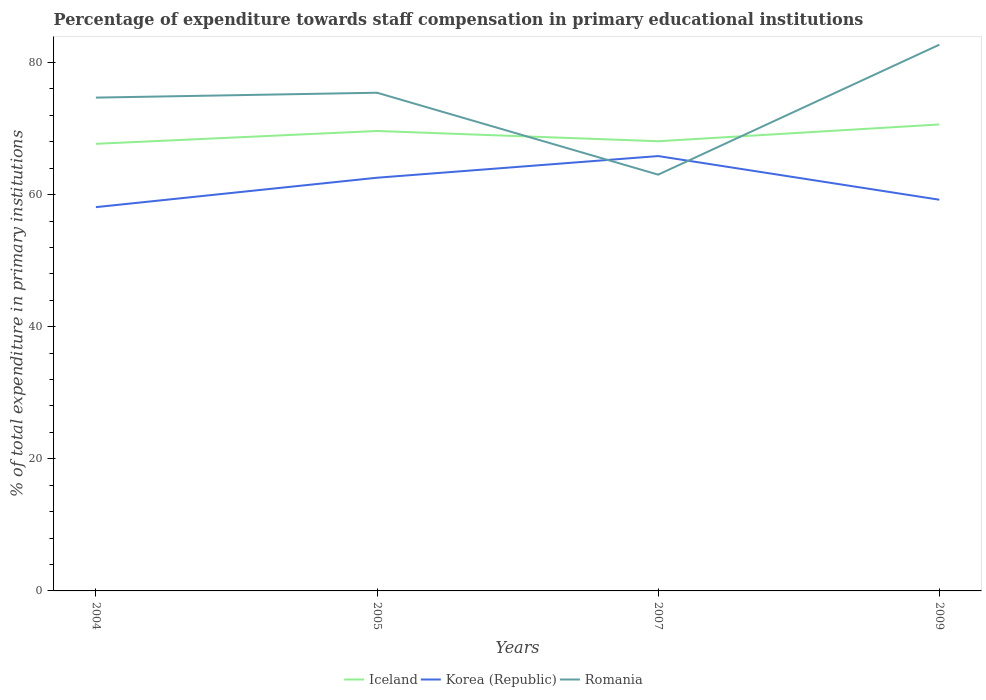How many different coloured lines are there?
Keep it short and to the point. 3. Does the line corresponding to Korea (Republic) intersect with the line corresponding to Romania?
Keep it short and to the point. Yes. Across all years, what is the maximum percentage of expenditure towards staff compensation in Korea (Republic)?
Your answer should be very brief. 58.11. What is the total percentage of expenditure towards staff compensation in Iceland in the graph?
Provide a short and direct response. -0.39. What is the difference between the highest and the second highest percentage of expenditure towards staff compensation in Korea (Republic)?
Make the answer very short. 7.73. What is the difference between the highest and the lowest percentage of expenditure towards staff compensation in Romania?
Provide a succinct answer. 3. Is the percentage of expenditure towards staff compensation in Romania strictly greater than the percentage of expenditure towards staff compensation in Korea (Republic) over the years?
Your answer should be compact. No. How many lines are there?
Your answer should be compact. 3. How many years are there in the graph?
Give a very brief answer. 4. What is the difference between two consecutive major ticks on the Y-axis?
Provide a short and direct response. 20. Are the values on the major ticks of Y-axis written in scientific E-notation?
Give a very brief answer. No. Does the graph contain grids?
Provide a succinct answer. No. How are the legend labels stacked?
Give a very brief answer. Horizontal. What is the title of the graph?
Provide a succinct answer. Percentage of expenditure towards staff compensation in primary educational institutions. What is the label or title of the Y-axis?
Give a very brief answer. % of total expenditure in primary institutions. What is the % of total expenditure in primary institutions of Iceland in 2004?
Your response must be concise. 67.7. What is the % of total expenditure in primary institutions of Korea (Republic) in 2004?
Give a very brief answer. 58.11. What is the % of total expenditure in primary institutions in Romania in 2004?
Provide a short and direct response. 74.69. What is the % of total expenditure in primary institutions in Iceland in 2005?
Give a very brief answer. 69.64. What is the % of total expenditure in primary institutions of Korea (Republic) in 2005?
Your response must be concise. 62.56. What is the % of total expenditure in primary institutions in Romania in 2005?
Make the answer very short. 75.43. What is the % of total expenditure in primary institutions of Iceland in 2007?
Ensure brevity in your answer.  68.09. What is the % of total expenditure in primary institutions in Korea (Republic) in 2007?
Your answer should be compact. 65.84. What is the % of total expenditure in primary institutions of Romania in 2007?
Ensure brevity in your answer.  63.03. What is the % of total expenditure in primary institutions in Iceland in 2009?
Give a very brief answer. 70.63. What is the % of total expenditure in primary institutions in Korea (Republic) in 2009?
Make the answer very short. 59.23. What is the % of total expenditure in primary institutions in Romania in 2009?
Offer a very short reply. 82.7. Across all years, what is the maximum % of total expenditure in primary institutions in Iceland?
Offer a terse response. 70.63. Across all years, what is the maximum % of total expenditure in primary institutions of Korea (Republic)?
Keep it short and to the point. 65.84. Across all years, what is the maximum % of total expenditure in primary institutions in Romania?
Your response must be concise. 82.7. Across all years, what is the minimum % of total expenditure in primary institutions in Iceland?
Your response must be concise. 67.7. Across all years, what is the minimum % of total expenditure in primary institutions in Korea (Republic)?
Your response must be concise. 58.11. Across all years, what is the minimum % of total expenditure in primary institutions of Romania?
Your response must be concise. 63.03. What is the total % of total expenditure in primary institutions of Iceland in the graph?
Keep it short and to the point. 276.04. What is the total % of total expenditure in primary institutions in Korea (Republic) in the graph?
Offer a very short reply. 245.74. What is the total % of total expenditure in primary institutions in Romania in the graph?
Your answer should be very brief. 295.85. What is the difference between the % of total expenditure in primary institutions of Iceland in 2004 and that in 2005?
Your response must be concise. -1.94. What is the difference between the % of total expenditure in primary institutions of Korea (Republic) in 2004 and that in 2005?
Your answer should be compact. -4.45. What is the difference between the % of total expenditure in primary institutions of Romania in 2004 and that in 2005?
Ensure brevity in your answer.  -0.74. What is the difference between the % of total expenditure in primary institutions of Iceland in 2004 and that in 2007?
Ensure brevity in your answer.  -0.39. What is the difference between the % of total expenditure in primary institutions in Korea (Republic) in 2004 and that in 2007?
Make the answer very short. -7.73. What is the difference between the % of total expenditure in primary institutions of Romania in 2004 and that in 2007?
Provide a short and direct response. 11.66. What is the difference between the % of total expenditure in primary institutions in Iceland in 2004 and that in 2009?
Offer a terse response. -2.93. What is the difference between the % of total expenditure in primary institutions of Korea (Republic) in 2004 and that in 2009?
Your answer should be compact. -1.12. What is the difference between the % of total expenditure in primary institutions in Romania in 2004 and that in 2009?
Your response must be concise. -8.01. What is the difference between the % of total expenditure in primary institutions in Iceland in 2005 and that in 2007?
Your answer should be compact. 1.55. What is the difference between the % of total expenditure in primary institutions in Korea (Republic) in 2005 and that in 2007?
Make the answer very short. -3.28. What is the difference between the % of total expenditure in primary institutions in Romania in 2005 and that in 2007?
Give a very brief answer. 12.4. What is the difference between the % of total expenditure in primary institutions in Iceland in 2005 and that in 2009?
Give a very brief answer. -0.99. What is the difference between the % of total expenditure in primary institutions of Korea (Republic) in 2005 and that in 2009?
Your response must be concise. 3.33. What is the difference between the % of total expenditure in primary institutions in Romania in 2005 and that in 2009?
Provide a short and direct response. -7.27. What is the difference between the % of total expenditure in primary institutions of Iceland in 2007 and that in 2009?
Your answer should be very brief. -2.54. What is the difference between the % of total expenditure in primary institutions in Korea (Republic) in 2007 and that in 2009?
Your response must be concise. 6.61. What is the difference between the % of total expenditure in primary institutions in Romania in 2007 and that in 2009?
Provide a succinct answer. -19.67. What is the difference between the % of total expenditure in primary institutions of Iceland in 2004 and the % of total expenditure in primary institutions of Korea (Republic) in 2005?
Offer a very short reply. 5.14. What is the difference between the % of total expenditure in primary institutions of Iceland in 2004 and the % of total expenditure in primary institutions of Romania in 2005?
Give a very brief answer. -7.73. What is the difference between the % of total expenditure in primary institutions of Korea (Republic) in 2004 and the % of total expenditure in primary institutions of Romania in 2005?
Keep it short and to the point. -17.32. What is the difference between the % of total expenditure in primary institutions of Iceland in 2004 and the % of total expenditure in primary institutions of Korea (Republic) in 2007?
Ensure brevity in your answer.  1.86. What is the difference between the % of total expenditure in primary institutions in Iceland in 2004 and the % of total expenditure in primary institutions in Romania in 2007?
Offer a very short reply. 4.67. What is the difference between the % of total expenditure in primary institutions of Korea (Republic) in 2004 and the % of total expenditure in primary institutions of Romania in 2007?
Give a very brief answer. -4.92. What is the difference between the % of total expenditure in primary institutions of Iceland in 2004 and the % of total expenditure in primary institutions of Korea (Republic) in 2009?
Provide a succinct answer. 8.47. What is the difference between the % of total expenditure in primary institutions of Iceland in 2004 and the % of total expenditure in primary institutions of Romania in 2009?
Keep it short and to the point. -15.01. What is the difference between the % of total expenditure in primary institutions of Korea (Republic) in 2004 and the % of total expenditure in primary institutions of Romania in 2009?
Offer a terse response. -24.59. What is the difference between the % of total expenditure in primary institutions in Iceland in 2005 and the % of total expenditure in primary institutions in Korea (Republic) in 2007?
Offer a terse response. 3.8. What is the difference between the % of total expenditure in primary institutions of Iceland in 2005 and the % of total expenditure in primary institutions of Romania in 2007?
Your response must be concise. 6.61. What is the difference between the % of total expenditure in primary institutions of Korea (Republic) in 2005 and the % of total expenditure in primary institutions of Romania in 2007?
Ensure brevity in your answer.  -0.47. What is the difference between the % of total expenditure in primary institutions in Iceland in 2005 and the % of total expenditure in primary institutions in Korea (Republic) in 2009?
Give a very brief answer. 10.41. What is the difference between the % of total expenditure in primary institutions of Iceland in 2005 and the % of total expenditure in primary institutions of Romania in 2009?
Provide a succinct answer. -13.06. What is the difference between the % of total expenditure in primary institutions in Korea (Republic) in 2005 and the % of total expenditure in primary institutions in Romania in 2009?
Give a very brief answer. -20.14. What is the difference between the % of total expenditure in primary institutions of Iceland in 2007 and the % of total expenditure in primary institutions of Korea (Republic) in 2009?
Your response must be concise. 8.86. What is the difference between the % of total expenditure in primary institutions in Iceland in 2007 and the % of total expenditure in primary institutions in Romania in 2009?
Your response must be concise. -14.62. What is the difference between the % of total expenditure in primary institutions in Korea (Republic) in 2007 and the % of total expenditure in primary institutions in Romania in 2009?
Keep it short and to the point. -16.86. What is the average % of total expenditure in primary institutions of Iceland per year?
Give a very brief answer. 69.01. What is the average % of total expenditure in primary institutions of Korea (Republic) per year?
Keep it short and to the point. 61.43. What is the average % of total expenditure in primary institutions of Romania per year?
Offer a very short reply. 73.96. In the year 2004, what is the difference between the % of total expenditure in primary institutions of Iceland and % of total expenditure in primary institutions of Korea (Republic)?
Offer a terse response. 9.59. In the year 2004, what is the difference between the % of total expenditure in primary institutions in Iceland and % of total expenditure in primary institutions in Romania?
Provide a short and direct response. -6.99. In the year 2004, what is the difference between the % of total expenditure in primary institutions of Korea (Republic) and % of total expenditure in primary institutions of Romania?
Ensure brevity in your answer.  -16.58. In the year 2005, what is the difference between the % of total expenditure in primary institutions of Iceland and % of total expenditure in primary institutions of Korea (Republic)?
Offer a very short reply. 7.08. In the year 2005, what is the difference between the % of total expenditure in primary institutions of Iceland and % of total expenditure in primary institutions of Romania?
Make the answer very short. -5.79. In the year 2005, what is the difference between the % of total expenditure in primary institutions of Korea (Republic) and % of total expenditure in primary institutions of Romania?
Your answer should be very brief. -12.87. In the year 2007, what is the difference between the % of total expenditure in primary institutions in Iceland and % of total expenditure in primary institutions in Korea (Republic)?
Your answer should be very brief. 2.25. In the year 2007, what is the difference between the % of total expenditure in primary institutions in Iceland and % of total expenditure in primary institutions in Romania?
Your response must be concise. 5.06. In the year 2007, what is the difference between the % of total expenditure in primary institutions in Korea (Republic) and % of total expenditure in primary institutions in Romania?
Your response must be concise. 2.81. In the year 2009, what is the difference between the % of total expenditure in primary institutions in Iceland and % of total expenditure in primary institutions in Korea (Republic)?
Your response must be concise. 11.4. In the year 2009, what is the difference between the % of total expenditure in primary institutions in Iceland and % of total expenditure in primary institutions in Romania?
Your response must be concise. -12.08. In the year 2009, what is the difference between the % of total expenditure in primary institutions in Korea (Republic) and % of total expenditure in primary institutions in Romania?
Your answer should be very brief. -23.47. What is the ratio of the % of total expenditure in primary institutions in Iceland in 2004 to that in 2005?
Offer a very short reply. 0.97. What is the ratio of the % of total expenditure in primary institutions in Korea (Republic) in 2004 to that in 2005?
Keep it short and to the point. 0.93. What is the ratio of the % of total expenditure in primary institutions of Romania in 2004 to that in 2005?
Ensure brevity in your answer.  0.99. What is the ratio of the % of total expenditure in primary institutions in Iceland in 2004 to that in 2007?
Offer a terse response. 0.99. What is the ratio of the % of total expenditure in primary institutions of Korea (Republic) in 2004 to that in 2007?
Make the answer very short. 0.88. What is the ratio of the % of total expenditure in primary institutions of Romania in 2004 to that in 2007?
Your answer should be very brief. 1.19. What is the ratio of the % of total expenditure in primary institutions in Iceland in 2004 to that in 2009?
Offer a very short reply. 0.96. What is the ratio of the % of total expenditure in primary institutions in Romania in 2004 to that in 2009?
Your response must be concise. 0.9. What is the ratio of the % of total expenditure in primary institutions of Iceland in 2005 to that in 2007?
Your answer should be compact. 1.02. What is the ratio of the % of total expenditure in primary institutions in Korea (Republic) in 2005 to that in 2007?
Offer a very short reply. 0.95. What is the ratio of the % of total expenditure in primary institutions in Romania in 2005 to that in 2007?
Your answer should be very brief. 1.2. What is the ratio of the % of total expenditure in primary institutions in Korea (Republic) in 2005 to that in 2009?
Offer a terse response. 1.06. What is the ratio of the % of total expenditure in primary institutions of Romania in 2005 to that in 2009?
Your answer should be compact. 0.91. What is the ratio of the % of total expenditure in primary institutions in Iceland in 2007 to that in 2009?
Offer a terse response. 0.96. What is the ratio of the % of total expenditure in primary institutions in Korea (Republic) in 2007 to that in 2009?
Your response must be concise. 1.11. What is the ratio of the % of total expenditure in primary institutions of Romania in 2007 to that in 2009?
Your answer should be very brief. 0.76. What is the difference between the highest and the second highest % of total expenditure in primary institutions in Iceland?
Your response must be concise. 0.99. What is the difference between the highest and the second highest % of total expenditure in primary institutions in Korea (Republic)?
Make the answer very short. 3.28. What is the difference between the highest and the second highest % of total expenditure in primary institutions of Romania?
Your response must be concise. 7.27. What is the difference between the highest and the lowest % of total expenditure in primary institutions of Iceland?
Provide a short and direct response. 2.93. What is the difference between the highest and the lowest % of total expenditure in primary institutions in Korea (Republic)?
Provide a succinct answer. 7.73. What is the difference between the highest and the lowest % of total expenditure in primary institutions in Romania?
Your response must be concise. 19.67. 